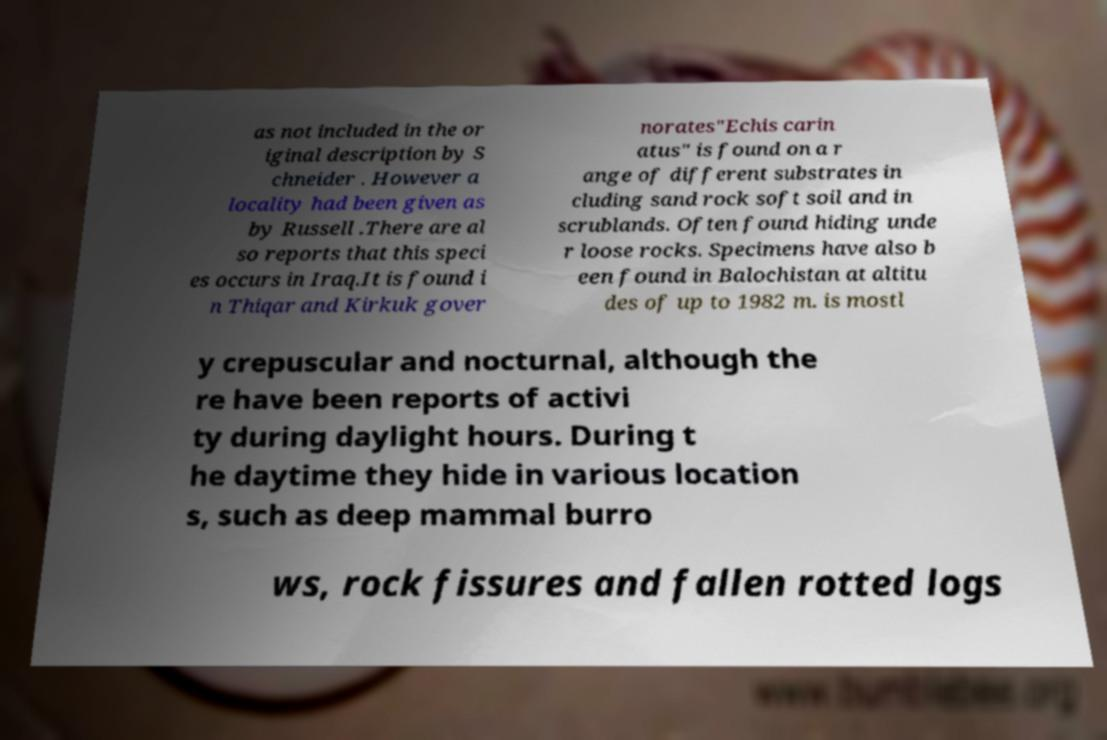Could you assist in decoding the text presented in this image and type it out clearly? as not included in the or iginal description by S chneider . However a locality had been given as by Russell .There are al so reports that this speci es occurs in Iraq.It is found i n Thiqar and Kirkuk gover norates"Echis carin atus" is found on a r ange of different substrates in cluding sand rock soft soil and in scrublands. Often found hiding unde r loose rocks. Specimens have also b een found in Balochistan at altitu des of up to 1982 m. is mostl y crepuscular and nocturnal, although the re have been reports of activi ty during daylight hours. During t he daytime they hide in various location s, such as deep mammal burro ws, rock fissures and fallen rotted logs 